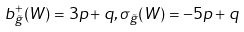<formula> <loc_0><loc_0><loc_500><loc_500>b ^ { + } _ { \tilde { g } } ( W ) = 3 p + q , \sigma _ { \tilde { g } } ( W ) = - 5 p + q</formula> 